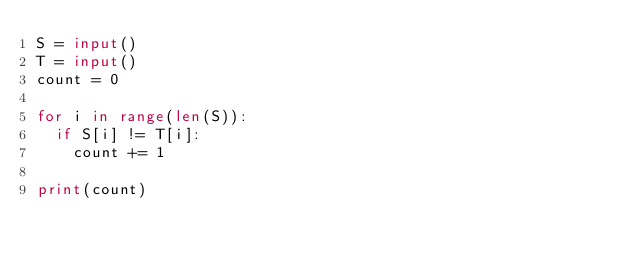Convert code to text. <code><loc_0><loc_0><loc_500><loc_500><_Python_>S = input()
T = input()
count = 0

for i in range(len(S)):
  if S[i] != T[i]:
    count += 1

print(count)
               </code> 